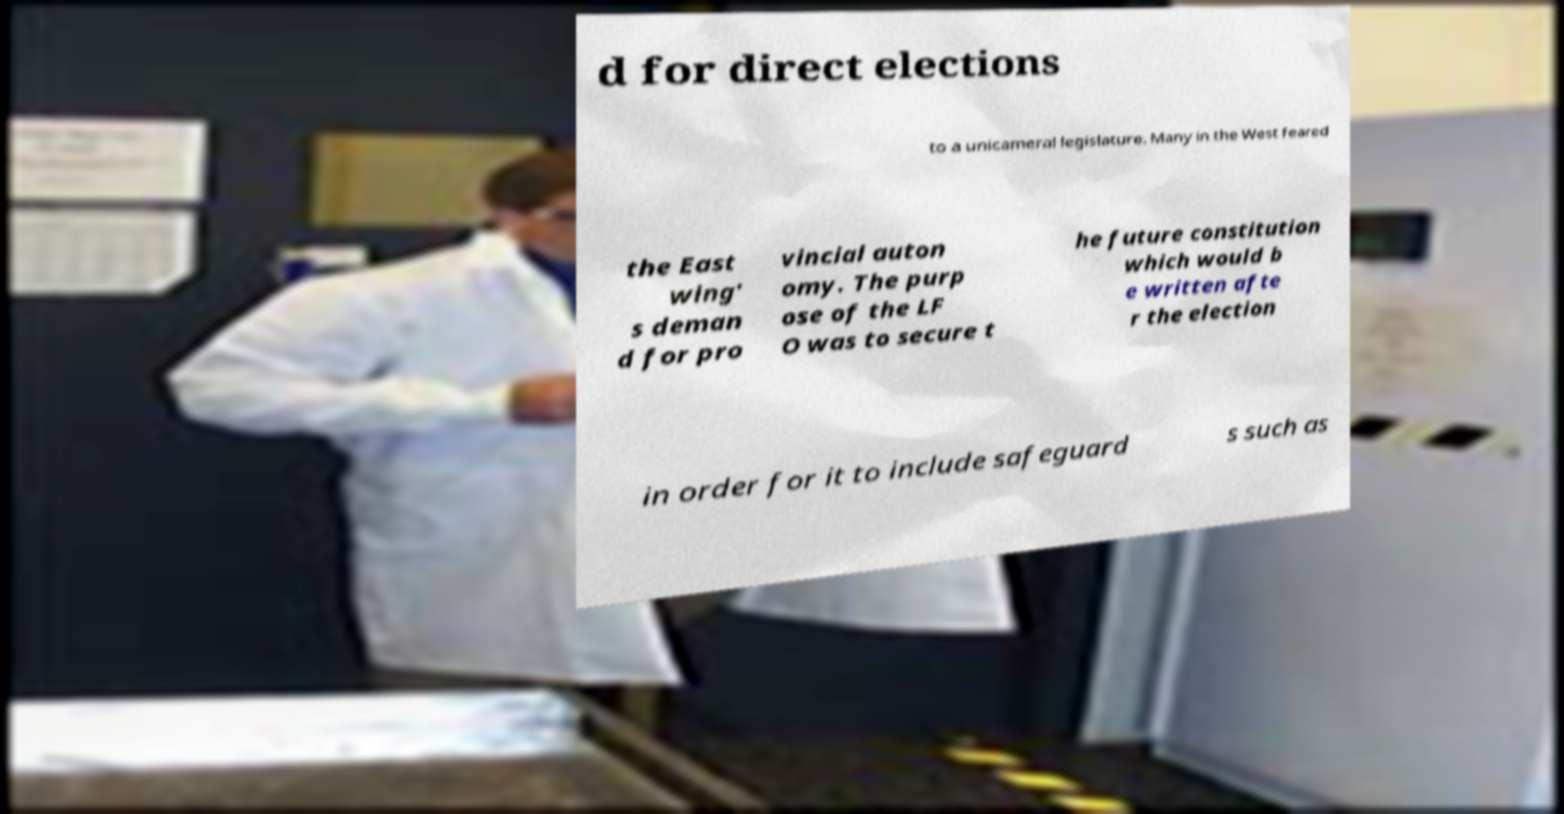Can you accurately transcribe the text from the provided image for me? d for direct elections to a unicameral legislature. Many in the West feared the East wing' s deman d for pro vincial auton omy. The purp ose of the LF O was to secure t he future constitution which would b e written afte r the election in order for it to include safeguard s such as 